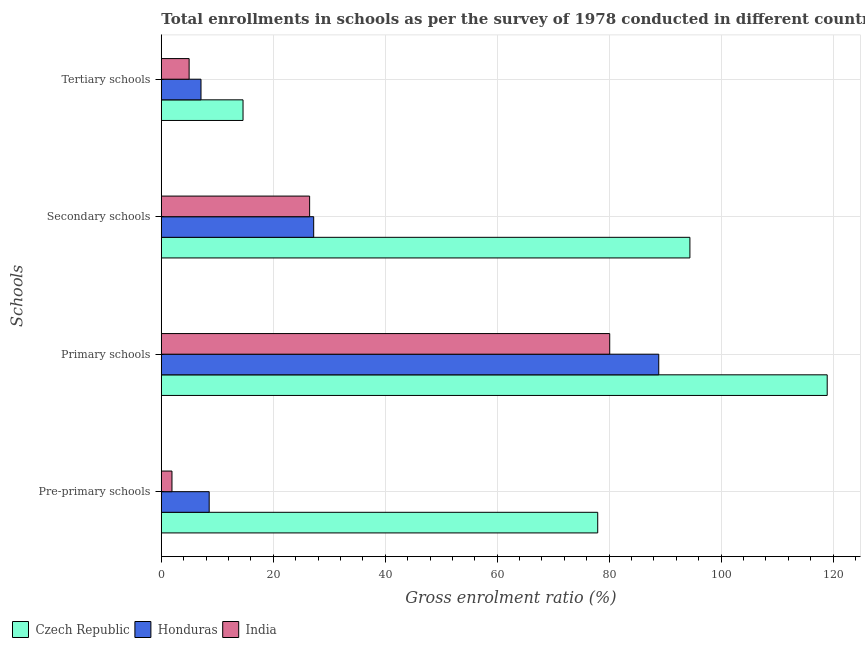How many groups of bars are there?
Your answer should be compact. 4. Are the number of bars per tick equal to the number of legend labels?
Provide a short and direct response. Yes. How many bars are there on the 3rd tick from the top?
Offer a very short reply. 3. What is the label of the 2nd group of bars from the top?
Offer a terse response. Secondary schools. What is the gross enrolment ratio in primary schools in Czech Republic?
Offer a very short reply. 118.96. Across all countries, what is the maximum gross enrolment ratio in primary schools?
Ensure brevity in your answer.  118.96. Across all countries, what is the minimum gross enrolment ratio in secondary schools?
Make the answer very short. 26.49. In which country was the gross enrolment ratio in secondary schools maximum?
Ensure brevity in your answer.  Czech Republic. What is the total gross enrolment ratio in pre-primary schools in the graph?
Ensure brevity in your answer.  88.41. What is the difference between the gross enrolment ratio in tertiary schools in Honduras and that in Czech Republic?
Provide a short and direct response. -7.51. What is the difference between the gross enrolment ratio in tertiary schools in Honduras and the gross enrolment ratio in primary schools in Czech Republic?
Your response must be concise. -111.87. What is the average gross enrolment ratio in pre-primary schools per country?
Your answer should be compact. 29.47. What is the difference between the gross enrolment ratio in primary schools and gross enrolment ratio in secondary schools in India?
Your answer should be compact. 53.61. What is the ratio of the gross enrolment ratio in secondary schools in India to that in Czech Republic?
Your answer should be very brief. 0.28. What is the difference between the highest and the second highest gross enrolment ratio in tertiary schools?
Your answer should be very brief. 7.51. What is the difference between the highest and the lowest gross enrolment ratio in pre-primary schools?
Keep it short and to the point. 76.06. In how many countries, is the gross enrolment ratio in secondary schools greater than the average gross enrolment ratio in secondary schools taken over all countries?
Offer a terse response. 1. Is it the case that in every country, the sum of the gross enrolment ratio in secondary schools and gross enrolment ratio in tertiary schools is greater than the sum of gross enrolment ratio in primary schools and gross enrolment ratio in pre-primary schools?
Make the answer very short. No. What does the 1st bar from the top in Pre-primary schools represents?
Provide a succinct answer. India. What does the 2nd bar from the bottom in Primary schools represents?
Ensure brevity in your answer.  Honduras. Is it the case that in every country, the sum of the gross enrolment ratio in pre-primary schools and gross enrolment ratio in primary schools is greater than the gross enrolment ratio in secondary schools?
Make the answer very short. Yes. How many bars are there?
Keep it short and to the point. 12. Are all the bars in the graph horizontal?
Give a very brief answer. Yes. What is the difference between two consecutive major ticks on the X-axis?
Provide a short and direct response. 20. Does the graph contain any zero values?
Your answer should be very brief. No. Does the graph contain grids?
Ensure brevity in your answer.  Yes. Where does the legend appear in the graph?
Provide a short and direct response. Bottom left. How are the legend labels stacked?
Provide a short and direct response. Horizontal. What is the title of the graph?
Ensure brevity in your answer.  Total enrollments in schools as per the survey of 1978 conducted in different countries. Does "Monaco" appear as one of the legend labels in the graph?
Provide a short and direct response. No. What is the label or title of the Y-axis?
Your response must be concise. Schools. What is the Gross enrolment ratio (%) in Czech Republic in Pre-primary schools?
Make the answer very short. 77.96. What is the Gross enrolment ratio (%) in Honduras in Pre-primary schools?
Provide a succinct answer. 8.55. What is the Gross enrolment ratio (%) in India in Pre-primary schools?
Offer a very short reply. 1.9. What is the Gross enrolment ratio (%) in Czech Republic in Primary schools?
Your answer should be very brief. 118.96. What is the Gross enrolment ratio (%) of Honduras in Primary schools?
Your answer should be compact. 88.86. What is the Gross enrolment ratio (%) of India in Primary schools?
Your answer should be very brief. 80.11. What is the Gross enrolment ratio (%) in Czech Republic in Secondary schools?
Your response must be concise. 94.43. What is the Gross enrolment ratio (%) of Honduras in Secondary schools?
Your answer should be very brief. 27.22. What is the Gross enrolment ratio (%) in India in Secondary schools?
Make the answer very short. 26.49. What is the Gross enrolment ratio (%) in Czech Republic in Tertiary schools?
Your answer should be compact. 14.6. What is the Gross enrolment ratio (%) in Honduras in Tertiary schools?
Provide a short and direct response. 7.09. What is the Gross enrolment ratio (%) of India in Tertiary schools?
Give a very brief answer. 4.97. Across all Schools, what is the maximum Gross enrolment ratio (%) in Czech Republic?
Offer a very short reply. 118.96. Across all Schools, what is the maximum Gross enrolment ratio (%) in Honduras?
Offer a terse response. 88.86. Across all Schools, what is the maximum Gross enrolment ratio (%) of India?
Your response must be concise. 80.11. Across all Schools, what is the minimum Gross enrolment ratio (%) in Czech Republic?
Your answer should be very brief. 14.6. Across all Schools, what is the minimum Gross enrolment ratio (%) of Honduras?
Your response must be concise. 7.09. Across all Schools, what is the minimum Gross enrolment ratio (%) in India?
Offer a very short reply. 1.9. What is the total Gross enrolment ratio (%) of Czech Republic in the graph?
Your answer should be very brief. 305.94. What is the total Gross enrolment ratio (%) of Honduras in the graph?
Your answer should be compact. 131.72. What is the total Gross enrolment ratio (%) in India in the graph?
Make the answer very short. 113.47. What is the difference between the Gross enrolment ratio (%) of Czech Republic in Pre-primary schools and that in Primary schools?
Offer a terse response. -40.99. What is the difference between the Gross enrolment ratio (%) in Honduras in Pre-primary schools and that in Primary schools?
Offer a terse response. -80.31. What is the difference between the Gross enrolment ratio (%) in India in Pre-primary schools and that in Primary schools?
Provide a succinct answer. -78.2. What is the difference between the Gross enrolment ratio (%) in Czech Republic in Pre-primary schools and that in Secondary schools?
Provide a short and direct response. -16.47. What is the difference between the Gross enrolment ratio (%) in Honduras in Pre-primary schools and that in Secondary schools?
Ensure brevity in your answer.  -18.67. What is the difference between the Gross enrolment ratio (%) in India in Pre-primary schools and that in Secondary schools?
Make the answer very short. -24.59. What is the difference between the Gross enrolment ratio (%) of Czech Republic in Pre-primary schools and that in Tertiary schools?
Provide a short and direct response. 63.36. What is the difference between the Gross enrolment ratio (%) in Honduras in Pre-primary schools and that in Tertiary schools?
Offer a very short reply. 1.46. What is the difference between the Gross enrolment ratio (%) of India in Pre-primary schools and that in Tertiary schools?
Provide a succinct answer. -3.07. What is the difference between the Gross enrolment ratio (%) of Czech Republic in Primary schools and that in Secondary schools?
Give a very brief answer. 24.53. What is the difference between the Gross enrolment ratio (%) in Honduras in Primary schools and that in Secondary schools?
Your answer should be compact. 61.65. What is the difference between the Gross enrolment ratio (%) in India in Primary schools and that in Secondary schools?
Provide a succinct answer. 53.61. What is the difference between the Gross enrolment ratio (%) in Czech Republic in Primary schools and that in Tertiary schools?
Your response must be concise. 104.36. What is the difference between the Gross enrolment ratio (%) of Honduras in Primary schools and that in Tertiary schools?
Offer a very short reply. 81.78. What is the difference between the Gross enrolment ratio (%) of India in Primary schools and that in Tertiary schools?
Offer a very short reply. 75.14. What is the difference between the Gross enrolment ratio (%) in Czech Republic in Secondary schools and that in Tertiary schools?
Give a very brief answer. 79.83. What is the difference between the Gross enrolment ratio (%) of Honduras in Secondary schools and that in Tertiary schools?
Your response must be concise. 20.13. What is the difference between the Gross enrolment ratio (%) of India in Secondary schools and that in Tertiary schools?
Ensure brevity in your answer.  21.53. What is the difference between the Gross enrolment ratio (%) in Czech Republic in Pre-primary schools and the Gross enrolment ratio (%) in Honduras in Primary schools?
Make the answer very short. -10.9. What is the difference between the Gross enrolment ratio (%) of Czech Republic in Pre-primary schools and the Gross enrolment ratio (%) of India in Primary schools?
Ensure brevity in your answer.  -2.14. What is the difference between the Gross enrolment ratio (%) in Honduras in Pre-primary schools and the Gross enrolment ratio (%) in India in Primary schools?
Provide a short and direct response. -71.55. What is the difference between the Gross enrolment ratio (%) of Czech Republic in Pre-primary schools and the Gross enrolment ratio (%) of Honduras in Secondary schools?
Provide a succinct answer. 50.74. What is the difference between the Gross enrolment ratio (%) in Czech Republic in Pre-primary schools and the Gross enrolment ratio (%) in India in Secondary schools?
Your answer should be compact. 51.47. What is the difference between the Gross enrolment ratio (%) in Honduras in Pre-primary schools and the Gross enrolment ratio (%) in India in Secondary schools?
Keep it short and to the point. -17.94. What is the difference between the Gross enrolment ratio (%) of Czech Republic in Pre-primary schools and the Gross enrolment ratio (%) of Honduras in Tertiary schools?
Keep it short and to the point. 70.87. What is the difference between the Gross enrolment ratio (%) of Czech Republic in Pre-primary schools and the Gross enrolment ratio (%) of India in Tertiary schools?
Provide a succinct answer. 72.99. What is the difference between the Gross enrolment ratio (%) in Honduras in Pre-primary schools and the Gross enrolment ratio (%) in India in Tertiary schools?
Provide a short and direct response. 3.58. What is the difference between the Gross enrolment ratio (%) in Czech Republic in Primary schools and the Gross enrolment ratio (%) in Honduras in Secondary schools?
Your response must be concise. 91.74. What is the difference between the Gross enrolment ratio (%) of Czech Republic in Primary schools and the Gross enrolment ratio (%) of India in Secondary schools?
Offer a terse response. 92.46. What is the difference between the Gross enrolment ratio (%) of Honduras in Primary schools and the Gross enrolment ratio (%) of India in Secondary schools?
Give a very brief answer. 62.37. What is the difference between the Gross enrolment ratio (%) of Czech Republic in Primary schools and the Gross enrolment ratio (%) of Honduras in Tertiary schools?
Make the answer very short. 111.87. What is the difference between the Gross enrolment ratio (%) in Czech Republic in Primary schools and the Gross enrolment ratio (%) in India in Tertiary schools?
Your response must be concise. 113.99. What is the difference between the Gross enrolment ratio (%) in Honduras in Primary schools and the Gross enrolment ratio (%) in India in Tertiary schools?
Offer a very short reply. 83.9. What is the difference between the Gross enrolment ratio (%) of Czech Republic in Secondary schools and the Gross enrolment ratio (%) of Honduras in Tertiary schools?
Offer a very short reply. 87.34. What is the difference between the Gross enrolment ratio (%) in Czech Republic in Secondary schools and the Gross enrolment ratio (%) in India in Tertiary schools?
Offer a terse response. 89.46. What is the difference between the Gross enrolment ratio (%) of Honduras in Secondary schools and the Gross enrolment ratio (%) of India in Tertiary schools?
Your answer should be very brief. 22.25. What is the average Gross enrolment ratio (%) in Czech Republic per Schools?
Provide a succinct answer. 76.49. What is the average Gross enrolment ratio (%) of Honduras per Schools?
Provide a short and direct response. 32.93. What is the average Gross enrolment ratio (%) in India per Schools?
Your answer should be compact. 28.37. What is the difference between the Gross enrolment ratio (%) of Czech Republic and Gross enrolment ratio (%) of Honduras in Pre-primary schools?
Your answer should be compact. 69.41. What is the difference between the Gross enrolment ratio (%) of Czech Republic and Gross enrolment ratio (%) of India in Pre-primary schools?
Ensure brevity in your answer.  76.06. What is the difference between the Gross enrolment ratio (%) of Honduras and Gross enrolment ratio (%) of India in Pre-primary schools?
Offer a very short reply. 6.65. What is the difference between the Gross enrolment ratio (%) of Czech Republic and Gross enrolment ratio (%) of Honduras in Primary schools?
Your answer should be compact. 30.09. What is the difference between the Gross enrolment ratio (%) in Czech Republic and Gross enrolment ratio (%) in India in Primary schools?
Your answer should be compact. 38.85. What is the difference between the Gross enrolment ratio (%) of Honduras and Gross enrolment ratio (%) of India in Primary schools?
Your answer should be very brief. 8.76. What is the difference between the Gross enrolment ratio (%) in Czech Republic and Gross enrolment ratio (%) in Honduras in Secondary schools?
Your answer should be compact. 67.21. What is the difference between the Gross enrolment ratio (%) in Czech Republic and Gross enrolment ratio (%) in India in Secondary schools?
Make the answer very short. 67.94. What is the difference between the Gross enrolment ratio (%) of Honduras and Gross enrolment ratio (%) of India in Secondary schools?
Keep it short and to the point. 0.73. What is the difference between the Gross enrolment ratio (%) of Czech Republic and Gross enrolment ratio (%) of Honduras in Tertiary schools?
Make the answer very short. 7.51. What is the difference between the Gross enrolment ratio (%) in Czech Republic and Gross enrolment ratio (%) in India in Tertiary schools?
Keep it short and to the point. 9.63. What is the difference between the Gross enrolment ratio (%) of Honduras and Gross enrolment ratio (%) of India in Tertiary schools?
Make the answer very short. 2.12. What is the ratio of the Gross enrolment ratio (%) in Czech Republic in Pre-primary schools to that in Primary schools?
Provide a succinct answer. 0.66. What is the ratio of the Gross enrolment ratio (%) in Honduras in Pre-primary schools to that in Primary schools?
Provide a succinct answer. 0.1. What is the ratio of the Gross enrolment ratio (%) of India in Pre-primary schools to that in Primary schools?
Your response must be concise. 0.02. What is the ratio of the Gross enrolment ratio (%) in Czech Republic in Pre-primary schools to that in Secondary schools?
Keep it short and to the point. 0.83. What is the ratio of the Gross enrolment ratio (%) of Honduras in Pre-primary schools to that in Secondary schools?
Your answer should be compact. 0.31. What is the ratio of the Gross enrolment ratio (%) of India in Pre-primary schools to that in Secondary schools?
Your response must be concise. 0.07. What is the ratio of the Gross enrolment ratio (%) of Czech Republic in Pre-primary schools to that in Tertiary schools?
Ensure brevity in your answer.  5.34. What is the ratio of the Gross enrolment ratio (%) in Honduras in Pre-primary schools to that in Tertiary schools?
Make the answer very short. 1.21. What is the ratio of the Gross enrolment ratio (%) in India in Pre-primary schools to that in Tertiary schools?
Offer a terse response. 0.38. What is the ratio of the Gross enrolment ratio (%) of Czech Republic in Primary schools to that in Secondary schools?
Offer a very short reply. 1.26. What is the ratio of the Gross enrolment ratio (%) in Honduras in Primary schools to that in Secondary schools?
Offer a terse response. 3.26. What is the ratio of the Gross enrolment ratio (%) in India in Primary schools to that in Secondary schools?
Make the answer very short. 3.02. What is the ratio of the Gross enrolment ratio (%) of Czech Republic in Primary schools to that in Tertiary schools?
Your answer should be very brief. 8.15. What is the ratio of the Gross enrolment ratio (%) in Honduras in Primary schools to that in Tertiary schools?
Provide a succinct answer. 12.54. What is the ratio of the Gross enrolment ratio (%) of India in Primary schools to that in Tertiary schools?
Make the answer very short. 16.12. What is the ratio of the Gross enrolment ratio (%) of Czech Republic in Secondary schools to that in Tertiary schools?
Make the answer very short. 6.47. What is the ratio of the Gross enrolment ratio (%) in Honduras in Secondary schools to that in Tertiary schools?
Provide a short and direct response. 3.84. What is the ratio of the Gross enrolment ratio (%) of India in Secondary schools to that in Tertiary schools?
Your response must be concise. 5.33. What is the difference between the highest and the second highest Gross enrolment ratio (%) in Czech Republic?
Your answer should be very brief. 24.53. What is the difference between the highest and the second highest Gross enrolment ratio (%) of Honduras?
Your response must be concise. 61.65. What is the difference between the highest and the second highest Gross enrolment ratio (%) in India?
Your answer should be very brief. 53.61. What is the difference between the highest and the lowest Gross enrolment ratio (%) of Czech Republic?
Make the answer very short. 104.36. What is the difference between the highest and the lowest Gross enrolment ratio (%) in Honduras?
Keep it short and to the point. 81.78. What is the difference between the highest and the lowest Gross enrolment ratio (%) in India?
Give a very brief answer. 78.2. 